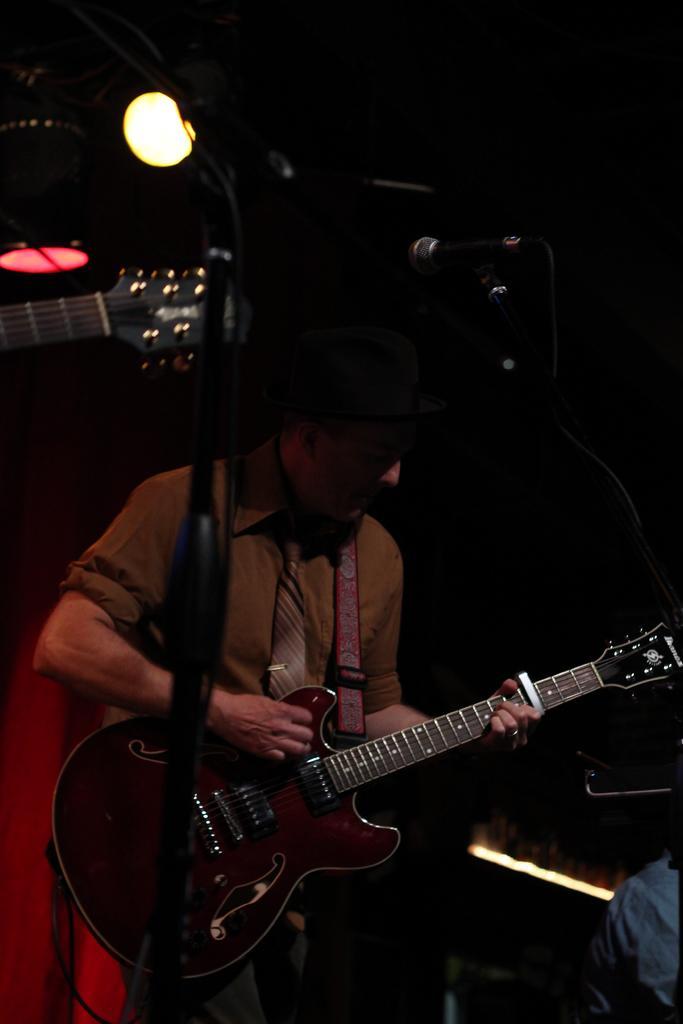How would you summarize this image in a sentence or two? In the image we can see there is a man who is holding guitar in his hand and he is wearing a black cap. 